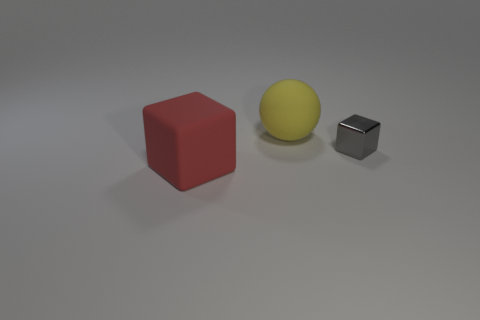Is there anything else that has the same material as the gray cube?
Your answer should be compact. No. How many objects are to the right of the yellow matte object and left of the small gray block?
Your response must be concise. 0. Is there any other thing that has the same shape as the big yellow thing?
Your response must be concise. No. What number of other things are there of the same size as the gray shiny thing?
Provide a short and direct response. 0. Does the red rubber object in front of the big yellow sphere have the same size as the rubber object behind the large red rubber block?
Give a very brief answer. Yes. What number of things are big purple rubber cubes or objects that are in front of the big yellow matte thing?
Make the answer very short. 2. What is the size of the cube left of the yellow sphere?
Your answer should be very brief. Large. Are there fewer gray objects that are to the left of the red rubber block than red things that are to the left of the tiny shiny object?
Offer a very short reply. Yes. There is a object that is in front of the large matte sphere and behind the red block; what is its material?
Give a very brief answer. Metal. What is the shape of the big matte thing that is in front of the block that is to the right of the red cube?
Keep it short and to the point. Cube. 